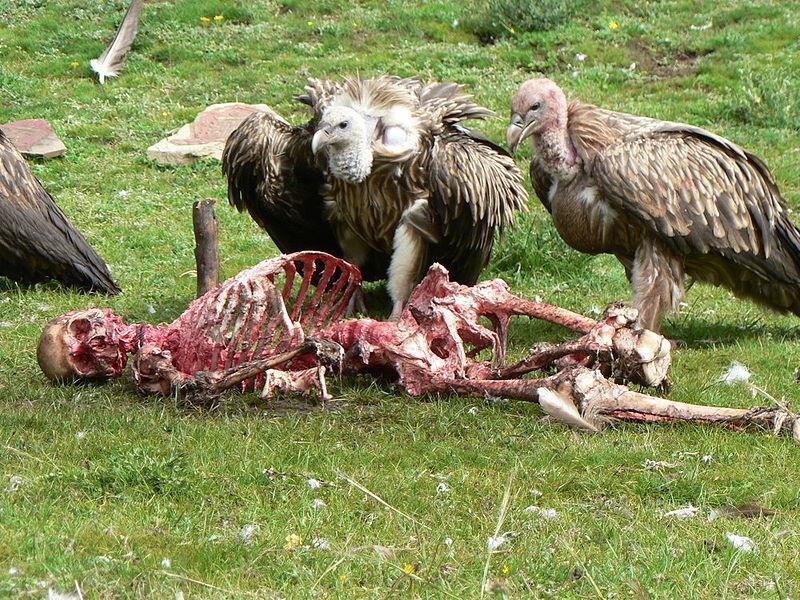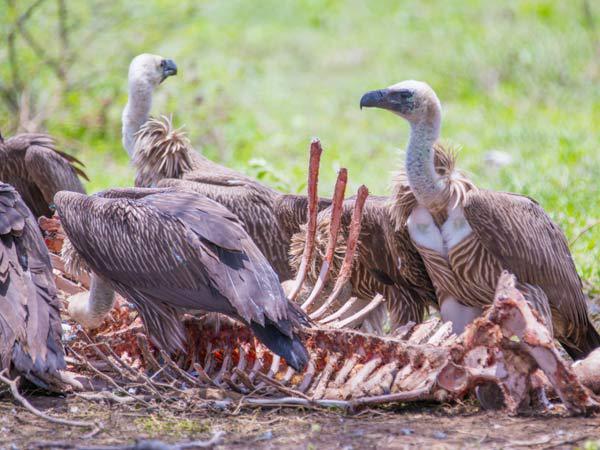The first image is the image on the left, the second image is the image on the right. Analyze the images presented: Is the assertion "An image shows vultures around a zebra carcass with some of its striped hide visible." valid? Answer yes or no. No. 